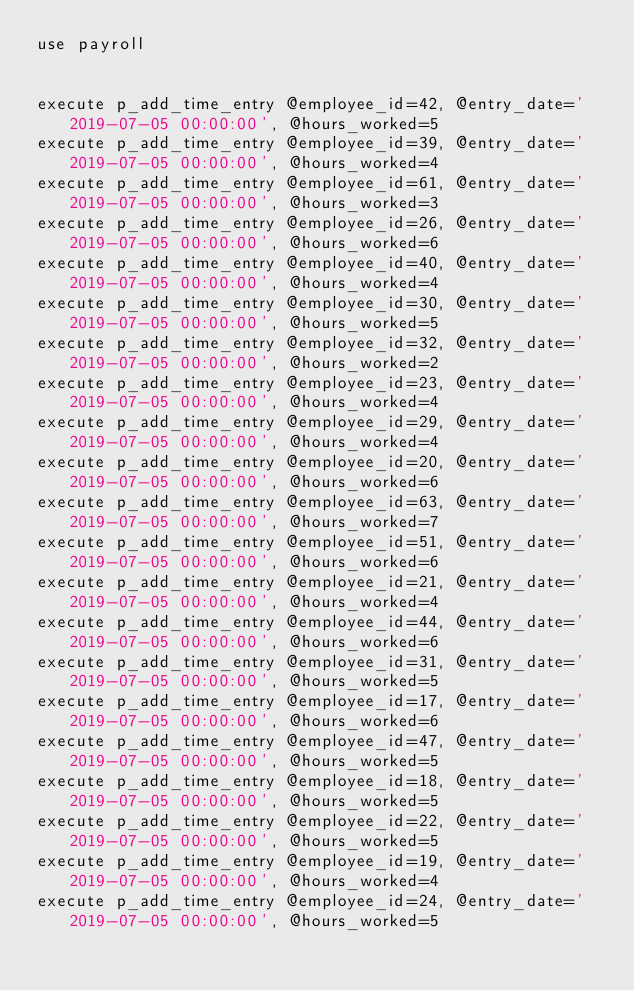Convert code to text. <code><loc_0><loc_0><loc_500><loc_500><_SQL_>use payroll


execute p_add_time_entry @employee_id=42, @entry_date='2019-07-05 00:00:00', @hours_worked=5
execute p_add_time_entry @employee_id=39, @entry_date='2019-07-05 00:00:00', @hours_worked=4
execute p_add_time_entry @employee_id=61, @entry_date='2019-07-05 00:00:00', @hours_worked=3
execute p_add_time_entry @employee_id=26, @entry_date='2019-07-05 00:00:00', @hours_worked=6
execute p_add_time_entry @employee_id=40, @entry_date='2019-07-05 00:00:00', @hours_worked=4
execute p_add_time_entry @employee_id=30, @entry_date='2019-07-05 00:00:00', @hours_worked=5
execute p_add_time_entry @employee_id=32, @entry_date='2019-07-05 00:00:00', @hours_worked=2
execute p_add_time_entry @employee_id=23, @entry_date='2019-07-05 00:00:00', @hours_worked=4
execute p_add_time_entry @employee_id=29, @entry_date='2019-07-05 00:00:00', @hours_worked=4
execute p_add_time_entry @employee_id=20, @entry_date='2019-07-05 00:00:00', @hours_worked=6
execute p_add_time_entry @employee_id=63, @entry_date='2019-07-05 00:00:00', @hours_worked=7
execute p_add_time_entry @employee_id=51, @entry_date='2019-07-05 00:00:00', @hours_worked=6
execute p_add_time_entry @employee_id=21, @entry_date='2019-07-05 00:00:00', @hours_worked=4
execute p_add_time_entry @employee_id=44, @entry_date='2019-07-05 00:00:00', @hours_worked=6
execute p_add_time_entry @employee_id=31, @entry_date='2019-07-05 00:00:00', @hours_worked=5
execute p_add_time_entry @employee_id=17, @entry_date='2019-07-05 00:00:00', @hours_worked=6
execute p_add_time_entry @employee_id=47, @entry_date='2019-07-05 00:00:00', @hours_worked=5
execute p_add_time_entry @employee_id=18, @entry_date='2019-07-05 00:00:00', @hours_worked=5
execute p_add_time_entry @employee_id=22, @entry_date='2019-07-05 00:00:00', @hours_worked=5
execute p_add_time_entry @employee_id=19, @entry_date='2019-07-05 00:00:00', @hours_worked=4
execute p_add_time_entry @employee_id=24, @entry_date='2019-07-05 00:00:00', @hours_worked=5

</code> 